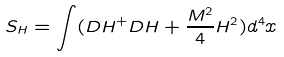<formula> <loc_0><loc_0><loc_500><loc_500>S _ { H } = \int ( D H ^ { + } D H + \frac { M ^ { 2 } } { 4 } H ^ { 2 } ) d ^ { 4 } x</formula> 